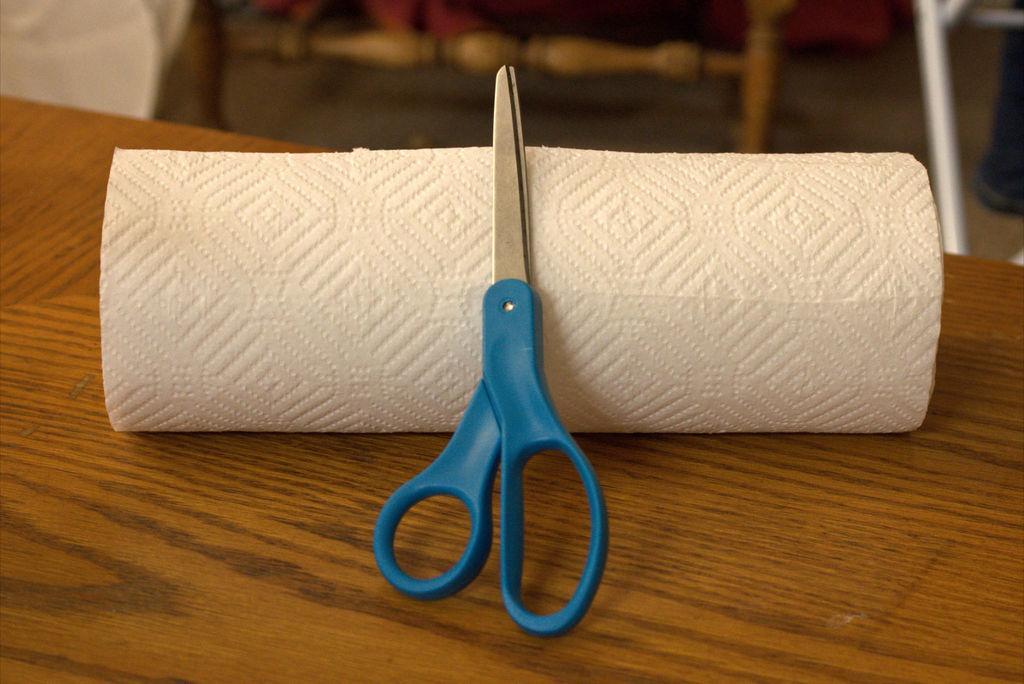Could you give a brief overview of what you see in this image? In this picture, scissor and paper are placed on the table. 